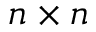<formula> <loc_0><loc_0><loc_500><loc_500>n \times n</formula> 